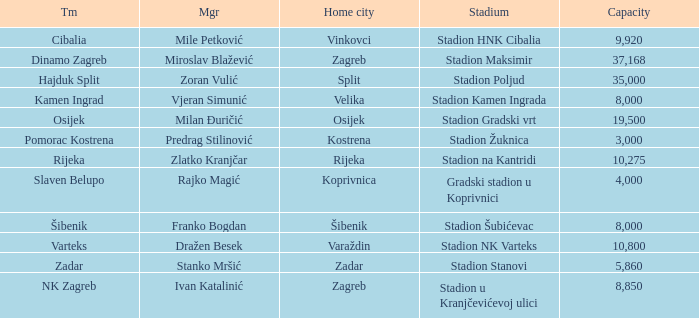What team that has a Home city of Zadar? Zadar. 